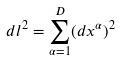<formula> <loc_0><loc_0><loc_500><loc_500>d l ^ { 2 } = \sum _ { \alpha = 1 } ^ { D } ( d x ^ { \alpha } ) ^ { 2 }</formula> 